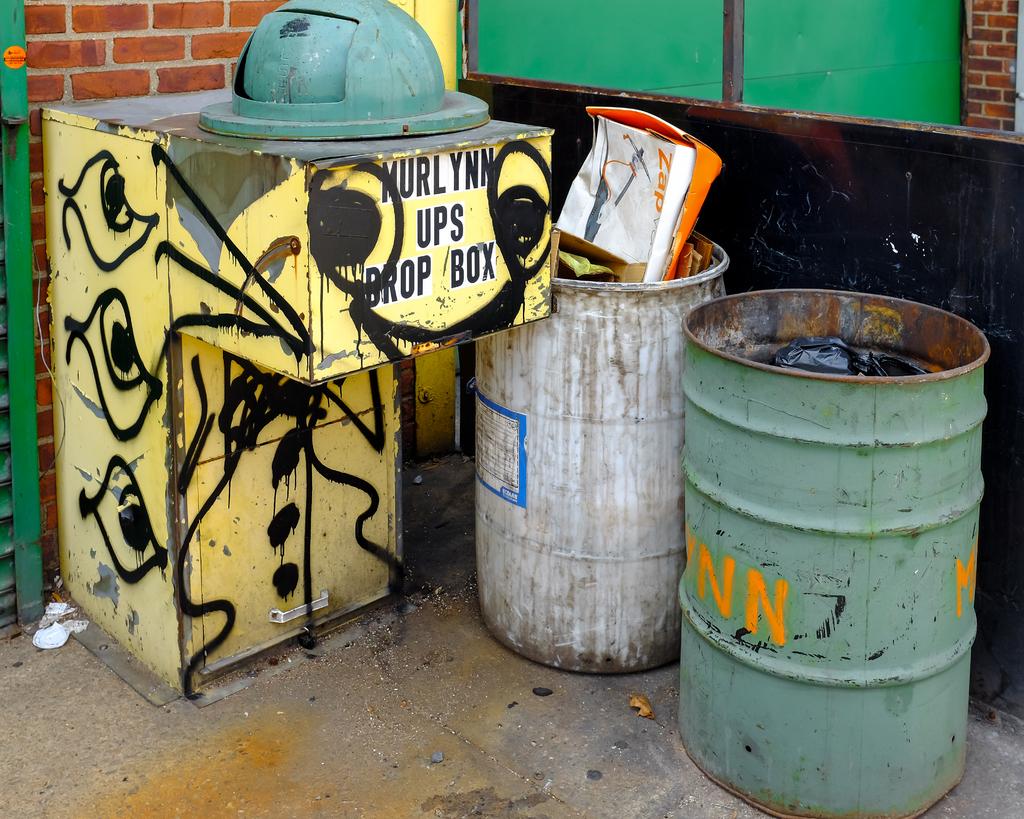What is this box used for?
Your answer should be compact. Ups drop box. What is this box for?
Provide a succinct answer. Ups drop box. 